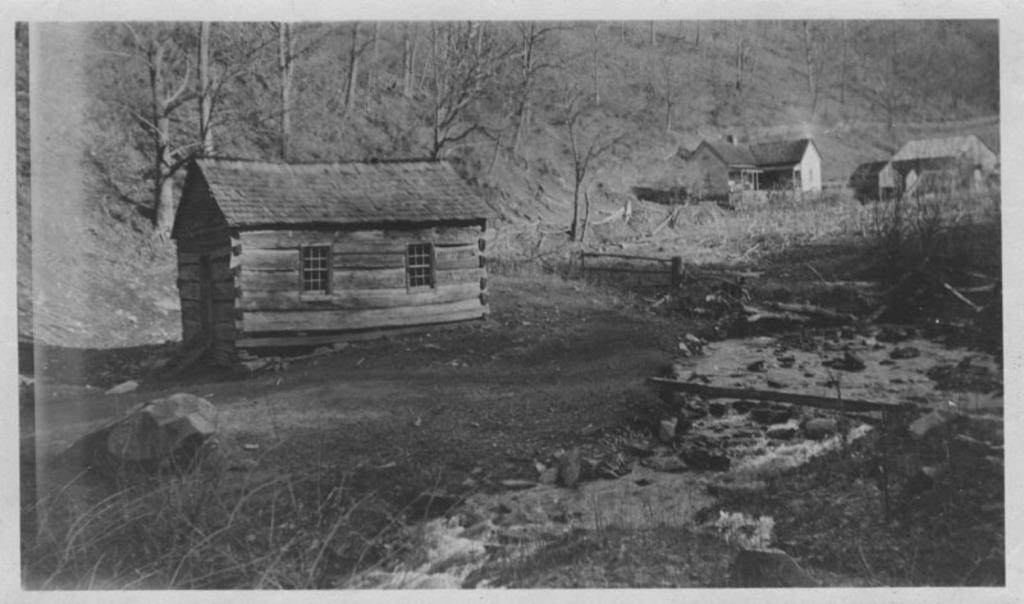Could you give a brief overview of what you see in this image? In this picture we can see stones, grass, water, houses, windows, wooden logs and some objects and in the background we can see trees. 